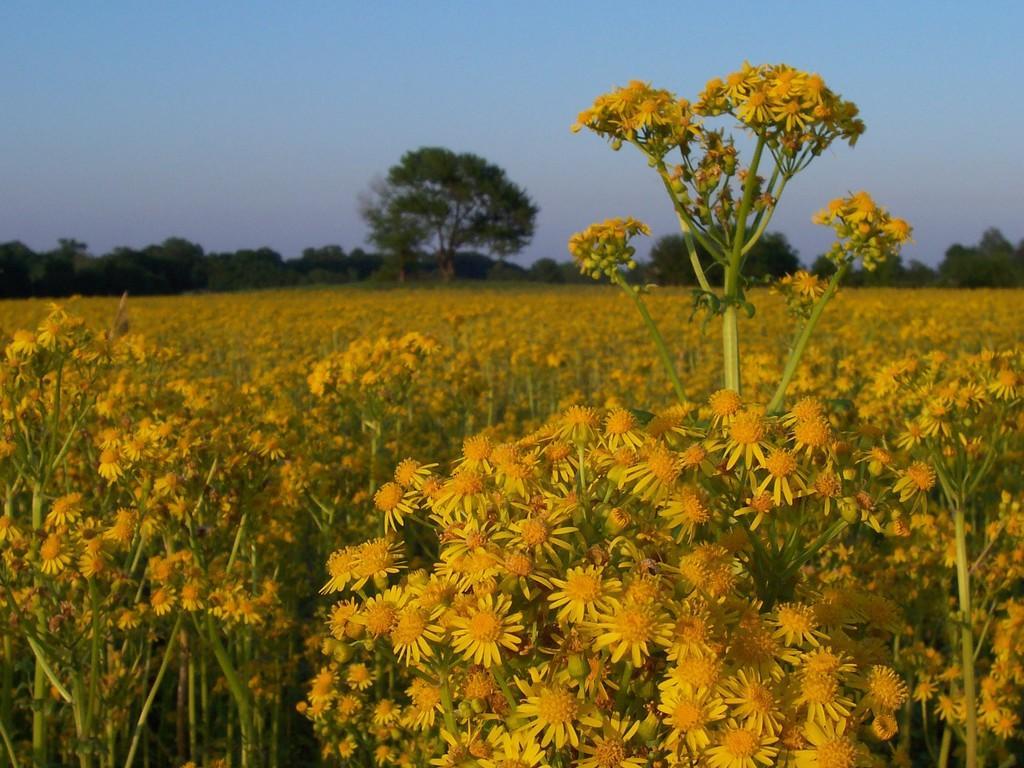Describe this image in one or two sentences. In this image I can see number of flowers which are yellow in color to the plants which are green in color. In the background I can see few trees and the sky. 